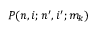Convert formula to latex. <formula><loc_0><loc_0><loc_500><loc_500>P ( n , i ; n ^ { \prime } , i ^ { \prime } ; m _ { k } )</formula> 